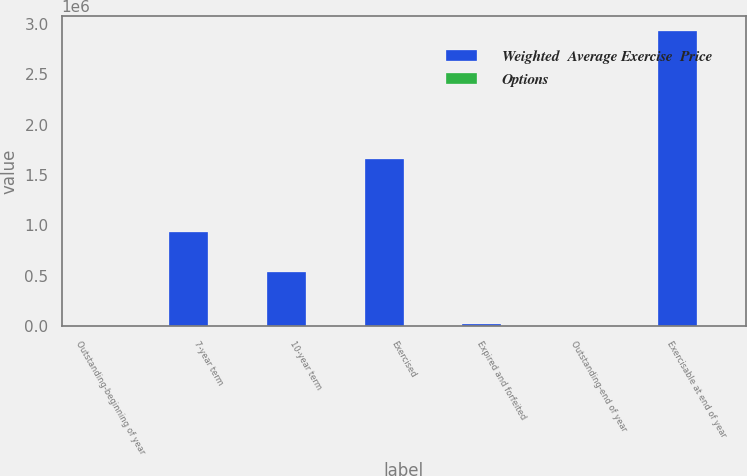Convert chart to OTSL. <chart><loc_0><loc_0><loc_500><loc_500><stacked_bar_chart><ecel><fcel>Outstanding-beginning of year<fcel>7-year term<fcel>10-year term<fcel>Exercised<fcel>Expired and forfeited<fcel>Outstanding-end of year<fcel>Exercisable at end of year<nl><fcel>Weighted  Average Exercise  Price<fcel>77.225<fcel>933286<fcel>535220<fcel>1.66181e+06<fcel>26488<fcel>77.225<fcel>2.92898e+06<nl><fcel>Options<fcel>44.64<fcel>77.19<fcel>77.26<fcel>36.84<fcel>57.94<fcel>53.59<fcel>43.79<nl></chart> 